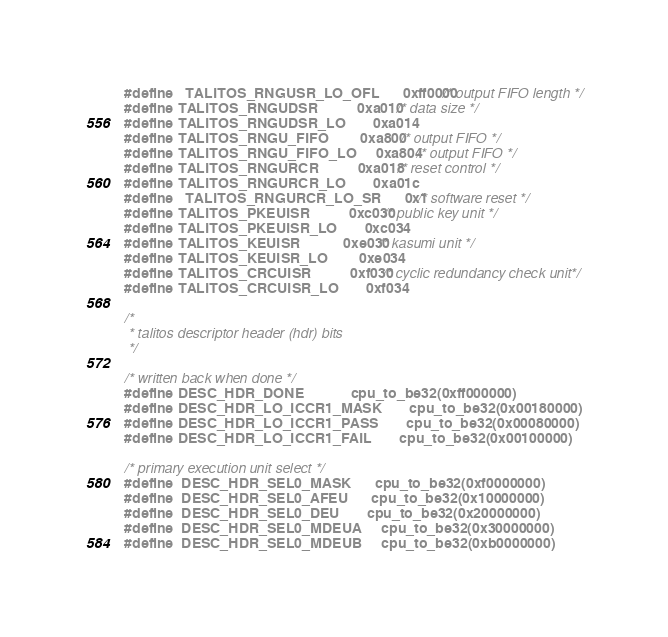<code> <loc_0><loc_0><loc_500><loc_500><_C_>#define   TALITOS_RNGUSR_LO_OFL		0xff0000/* output FIFO length */
#define TALITOS_RNGUDSR			0xa010	/* data size */
#define TALITOS_RNGUDSR_LO		0xa014
#define TALITOS_RNGU_FIFO		0xa800	/* output FIFO */
#define TALITOS_RNGU_FIFO_LO		0xa804	/* output FIFO */
#define TALITOS_RNGURCR			0xa018	/* reset control */
#define TALITOS_RNGURCR_LO		0xa01c
#define   TALITOS_RNGURCR_LO_SR		0x1	/* software reset */
#define TALITOS_PKEUISR			0xc030 /* public key unit */
#define TALITOS_PKEUISR_LO		0xc034
#define TALITOS_KEUISR			0xe030 /* kasumi unit */
#define TALITOS_KEUISR_LO		0xe034
#define TALITOS_CRCUISR			0xf030 /* cyclic redundancy check unit*/
#define TALITOS_CRCUISR_LO		0xf034

/*
 * talitos descriptor header (hdr) bits
 */

/* written back when done */
#define DESC_HDR_DONE			cpu_to_be32(0xff000000)
#define DESC_HDR_LO_ICCR1_MASK		cpu_to_be32(0x00180000)
#define DESC_HDR_LO_ICCR1_PASS		cpu_to_be32(0x00080000)
#define DESC_HDR_LO_ICCR1_FAIL		cpu_to_be32(0x00100000)

/* primary execution unit select */
#define	DESC_HDR_SEL0_MASK		cpu_to_be32(0xf0000000)
#define	DESC_HDR_SEL0_AFEU		cpu_to_be32(0x10000000)
#define	DESC_HDR_SEL0_DEU		cpu_to_be32(0x20000000)
#define	DESC_HDR_SEL0_MDEUA		cpu_to_be32(0x30000000)
#define	DESC_HDR_SEL0_MDEUB		cpu_to_be32(0xb0000000)</code> 